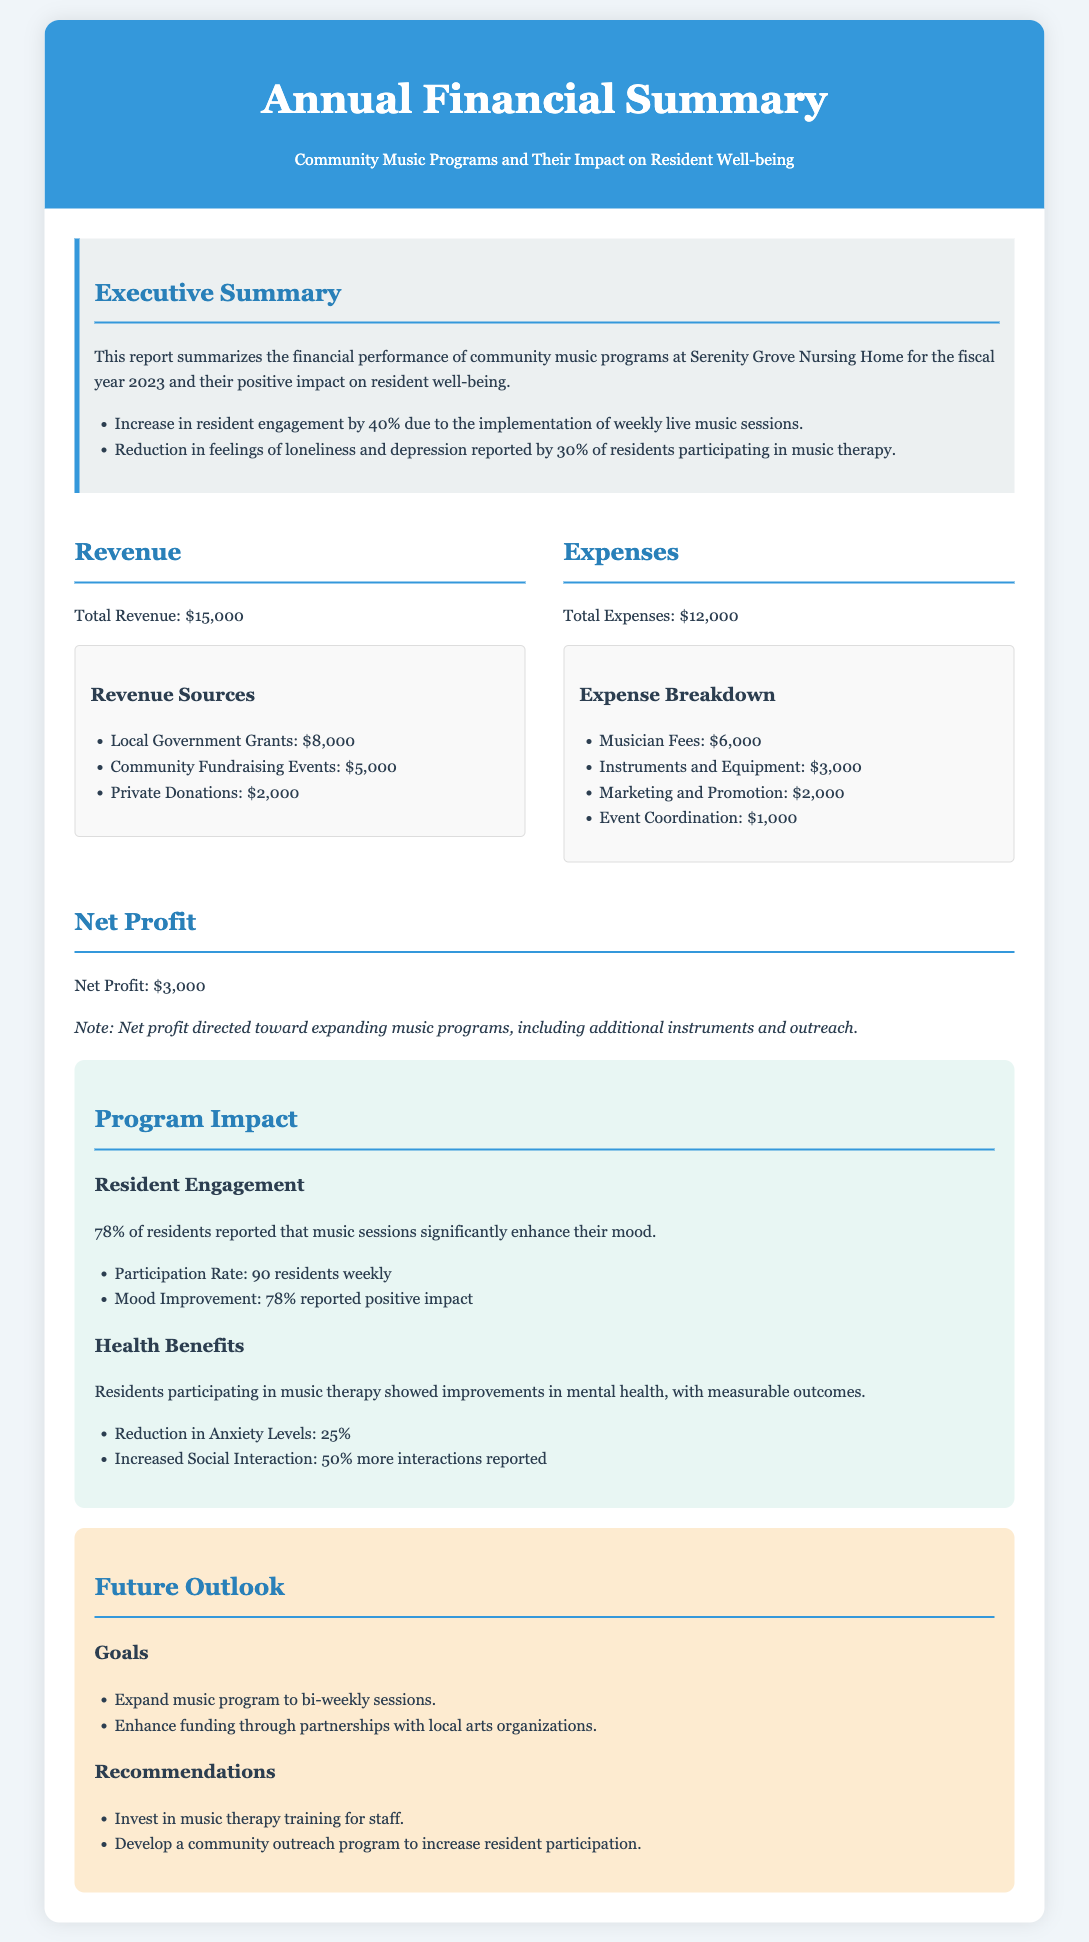what is the total revenue? The total revenue is stated in the document as $15,000.
Answer: $15,000 what were the primary sources of revenue? The document lists local government grants, community fundraising events, and private donations as the revenue sources.
Answer: Local Government Grants, Community Fundraising Events, Private Donations how much was spent on musician fees? The document specifies that musician fees amounted to $6,000.
Answer: $6,000 what percentage of residents reported improvements in mood due to music sessions? The document mentions that 78% of residents reported a positive impact on their mood.
Answer: 78% what is the net profit from the music programs? The net profit is derived from the total revenue minus total expenses, which is stated as $3,000.
Answer: $3,000 how many residents participate in music sessions weekly? The document indicates a participation rate of 90 residents weekly.
Answer: 90 residents what is one goal for the future of the music program? The document lists the expansion of the music program to bi-weekly sessions as a goal.
Answer: Expand to bi-weekly sessions what improvement in anxiety levels was reported by residents participating in music therapy? The document states that there was a reduction in anxiety levels by 25%.
Answer: 25% what is one recommendation made for improving the music program? The document suggests investing in music therapy training for staff as a recommendation.
Answer: Invest in music therapy training for staff 